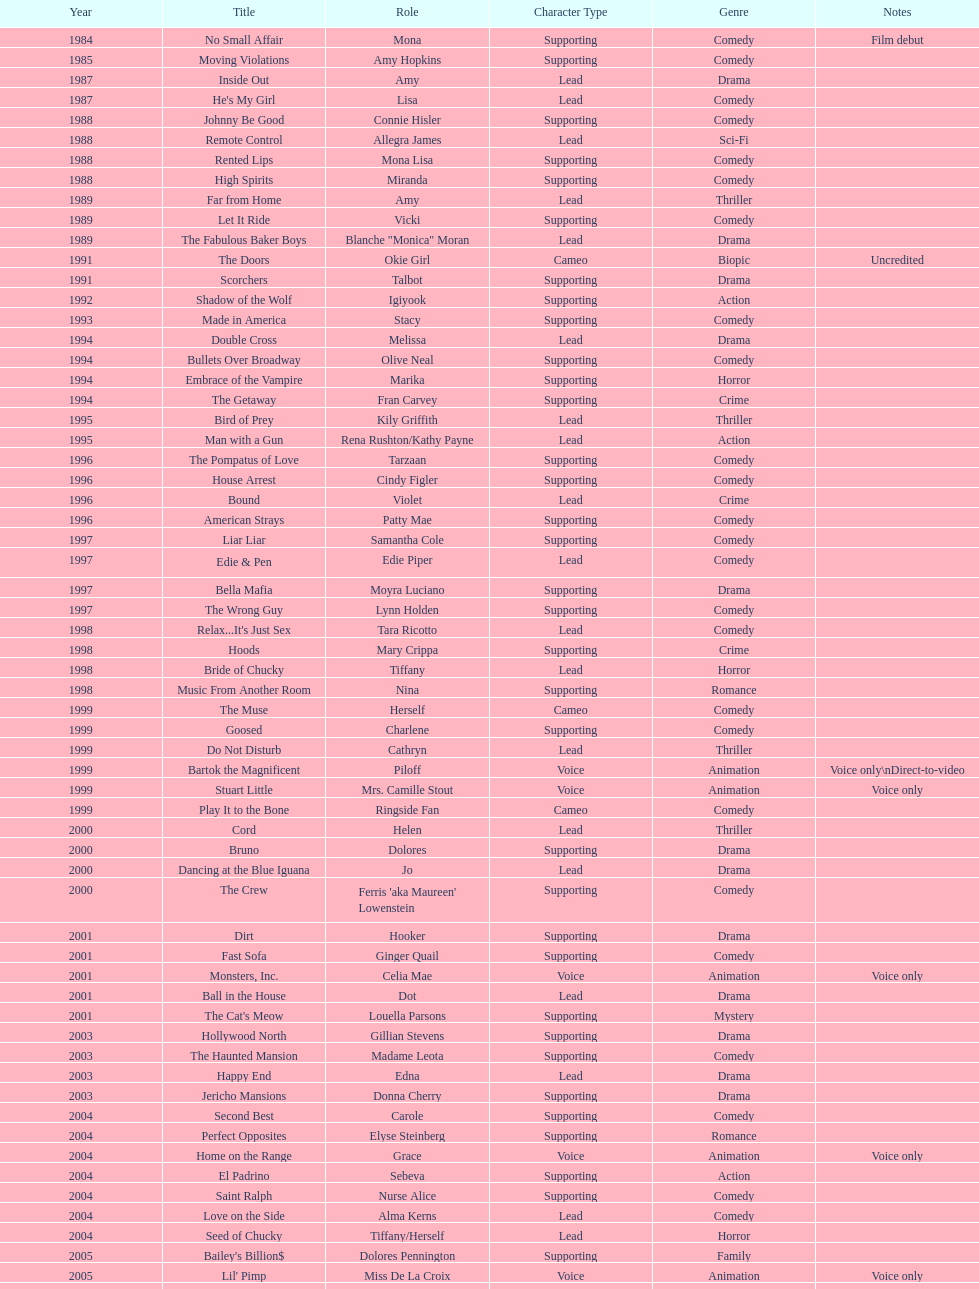How many films does jennifer tilly do a voice over role in? 5. Could you parse the entire table as a dict? {'header': ['Year', 'Title', 'Role', 'Character Type', 'Genre', 'Notes'], 'rows': [['1984', 'No Small Affair', 'Mona', 'Supporting', 'Comedy', 'Film debut'], ['1985', 'Moving Violations', 'Amy Hopkins', 'Supporting', 'Comedy', ''], ['1987', 'Inside Out', 'Amy', 'Lead', 'Drama', ''], ['1987', "He's My Girl", 'Lisa', 'Lead', 'Comedy', ''], ['1988', 'Johnny Be Good', 'Connie Hisler', 'Supporting', 'Comedy', ''], ['1988', 'Remote Control', 'Allegra James', 'Lead', 'Sci-Fi', ''], ['1988', 'Rented Lips', 'Mona Lisa', 'Supporting', 'Comedy', ''], ['1988', 'High Spirits', 'Miranda', 'Supporting', 'Comedy', ''], ['1989', 'Far from Home', 'Amy', 'Lead', 'Thriller', ''], ['1989', 'Let It Ride', 'Vicki', 'Supporting', 'Comedy', ''], ['1989', 'The Fabulous Baker Boys', 'Blanche "Monica" Moran', 'Lead', 'Drama', ''], ['1991', 'The Doors', 'Okie Girl', 'Cameo', 'Biopic', 'Uncredited'], ['1991', 'Scorchers', 'Talbot', 'Supporting', 'Drama', ''], ['1992', 'Shadow of the Wolf', 'Igiyook', 'Supporting', 'Action', ''], ['1993', 'Made in America', 'Stacy', 'Supporting', 'Comedy', ''], ['1994', 'Double Cross', 'Melissa', 'Lead', 'Drama', ''], ['1994', 'Bullets Over Broadway', 'Olive Neal', 'Supporting', 'Comedy', ''], ['1994', 'Embrace of the Vampire', 'Marika', 'Supporting', 'Horror', ''], ['1994', 'The Getaway', 'Fran Carvey', 'Supporting', 'Crime', ''], ['1995', 'Bird of Prey', 'Kily Griffith', 'Lead', 'Thriller', ''], ['1995', 'Man with a Gun', 'Rena Rushton/Kathy Payne', 'Lead', 'Action', ''], ['1996', 'The Pompatus of Love', 'Tarzaan', 'Supporting', 'Comedy', ''], ['1996', 'House Arrest', 'Cindy Figler', 'Supporting', 'Comedy', ''], ['1996', 'Bound', 'Violet', 'Lead', 'Crime', ''], ['1996', 'American Strays', 'Patty Mae', 'Supporting', 'Comedy', ''], ['1997', 'Liar Liar', 'Samantha Cole', 'Supporting', 'Comedy', ''], ['1997', 'Edie & Pen', 'Edie Piper', 'Lead', 'Comedy', ''], ['1997', 'Bella Mafia', 'Moyra Luciano', 'Supporting', 'Drama', ''], ['1997', 'The Wrong Guy', 'Lynn Holden', 'Supporting', 'Comedy', ''], ['1998', "Relax...It's Just Sex", 'Tara Ricotto', 'Lead', 'Comedy', ''], ['1998', 'Hoods', 'Mary Crippa', 'Supporting', 'Crime', ''], ['1998', 'Bride of Chucky', 'Tiffany', 'Lead', 'Horror', ''], ['1998', 'Music From Another Room', 'Nina', 'Supporting', 'Romance', ''], ['1999', 'The Muse', 'Herself', 'Cameo', 'Comedy', ''], ['1999', 'Goosed', 'Charlene', 'Supporting', 'Comedy', ''], ['1999', 'Do Not Disturb', 'Cathryn', 'Lead', 'Thriller', ''], ['1999', 'Bartok the Magnificent', 'Piloff', 'Voice', 'Animation', 'Voice only\\nDirect-to-video'], ['1999', 'Stuart Little', 'Mrs. Camille Stout', 'Voice', 'Animation', 'Voice only'], ['1999', 'Play It to the Bone', 'Ringside Fan', 'Cameo', 'Comedy', ''], ['2000', 'Cord', 'Helen', 'Lead', 'Thriller', ''], ['2000', 'Bruno', 'Dolores', 'Supporting', 'Drama', ''], ['2000', 'Dancing at the Blue Iguana', 'Jo', 'Lead', 'Drama', ''], ['2000', 'The Crew', "Ferris 'aka Maureen' Lowenstein", 'Supporting', 'Comedy', ''], ['2001', 'Dirt', 'Hooker', 'Supporting', 'Drama', ''], ['2001', 'Fast Sofa', 'Ginger Quail', 'Supporting', 'Comedy', ''], ['2001', 'Monsters, Inc.', 'Celia Mae', 'Voice', 'Animation', 'Voice only'], ['2001', 'Ball in the House', 'Dot', 'Lead', 'Drama', ''], ['2001', "The Cat's Meow", 'Louella Parsons', 'Supporting', 'Mystery', ''], ['2003', 'Hollywood North', 'Gillian Stevens', 'Supporting', 'Drama', ''], ['2003', 'The Haunted Mansion', 'Madame Leota', 'Supporting', 'Comedy', ''], ['2003', 'Happy End', 'Edna', 'Lead', 'Drama', ''], ['2003', 'Jericho Mansions', 'Donna Cherry', 'Supporting', 'Drama', ''], ['2004', 'Second Best', 'Carole', 'Supporting', 'Comedy', ''], ['2004', 'Perfect Opposites', 'Elyse Steinberg', 'Supporting', 'Romance', ''], ['2004', 'Home on the Range', 'Grace', 'Voice', 'Animation', 'Voice only'], ['2004', 'El Padrino', 'Sebeva', 'Supporting', 'Action', ''], ['2004', 'Saint Ralph', 'Nurse Alice', 'Supporting', 'Comedy', ''], ['2004', 'Love on the Side', 'Alma Kerns', 'Lead', 'Comedy', ''], ['2004', 'Seed of Chucky', 'Tiffany/Herself', 'Lead', 'Horror', ''], ['2005', "Bailey's Billion$", 'Dolores Pennington', 'Supporting', 'Family', ''], ['2005', "Lil' Pimp", 'Miss De La Croix', 'Voice', 'Animation', 'Voice only'], ['2005', 'The Civilization of Maxwell Bright', "Dr. O'Shannon", 'Supporting', 'Drama', ''], ['2005', 'Tideland', 'Queen Gunhilda', 'Supporting', 'Fantasy', ''], ['2006', 'The Poker Movie', 'Herself', 'Cameo', 'Documentary', ''], ['2007', 'Intervention', '', 'Lead', 'Drama', ''], ['2008', 'Deal', "Karen 'Razor' Jones", 'Supporting', 'Drama', ''], ['2008', 'The Caretaker', 'Miss Perry', 'Supporting', 'Horror', ''], ['2008', 'Bart Got a Room', 'Melinda', 'Supporting', 'Comedy', ''], ['2008', 'Inconceivable', "Salome 'Sally' Marsh", 'Lead', 'Drama', ''], ['2009', 'An American Girl: Chrissa Stands Strong', 'Mrs. Rundell', 'Supporting', 'Family', ''], ['2009', 'Imps', '', 'Cameo', 'Comedy', ''], ['2009', 'Made in Romania', 'Herself', 'Cameo', 'Comedy', ''], ['2009', 'Empire of Silver', 'Mrs. Landdeck', 'Supporting', 'Drama', ''], ['2010', 'The Making of Plus One', 'Amber', 'Supporting', 'Comedy', ''], ['2010', 'The Secret Lives of Dorks', 'Ms. Stewart', 'Supporting', 'Comedy', ''], ['2012', '30 Beats', 'Erika', 'Lead', 'Comedy', ''], ['2013', 'Curse of Chucky', 'Tiffany Ray', 'Cameo', 'Horror', 'Cameo, Direct-to-video']]} 